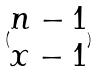<formula> <loc_0><loc_0><loc_500><loc_500>( \begin{matrix} n - 1 \\ x - 1 \end{matrix} )</formula> 